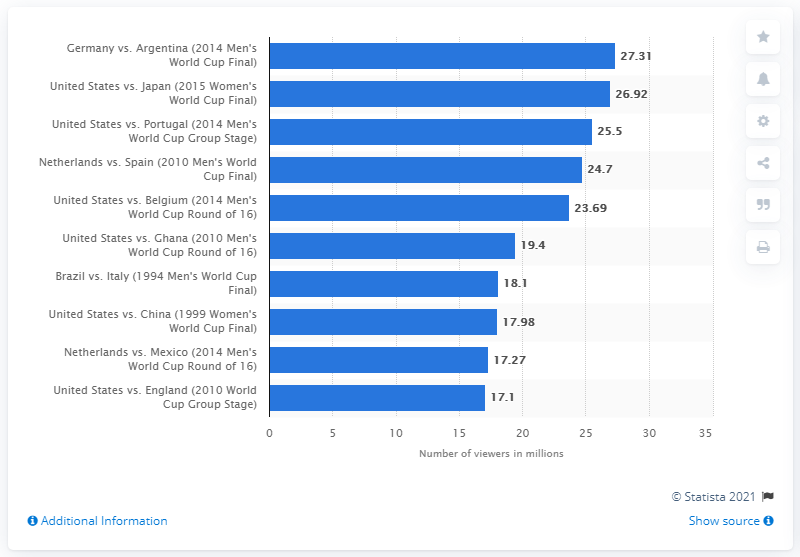Draw attention to some important aspects in this diagram. The 2014 Men's World Cup Final was watched by 26.92 million people. 